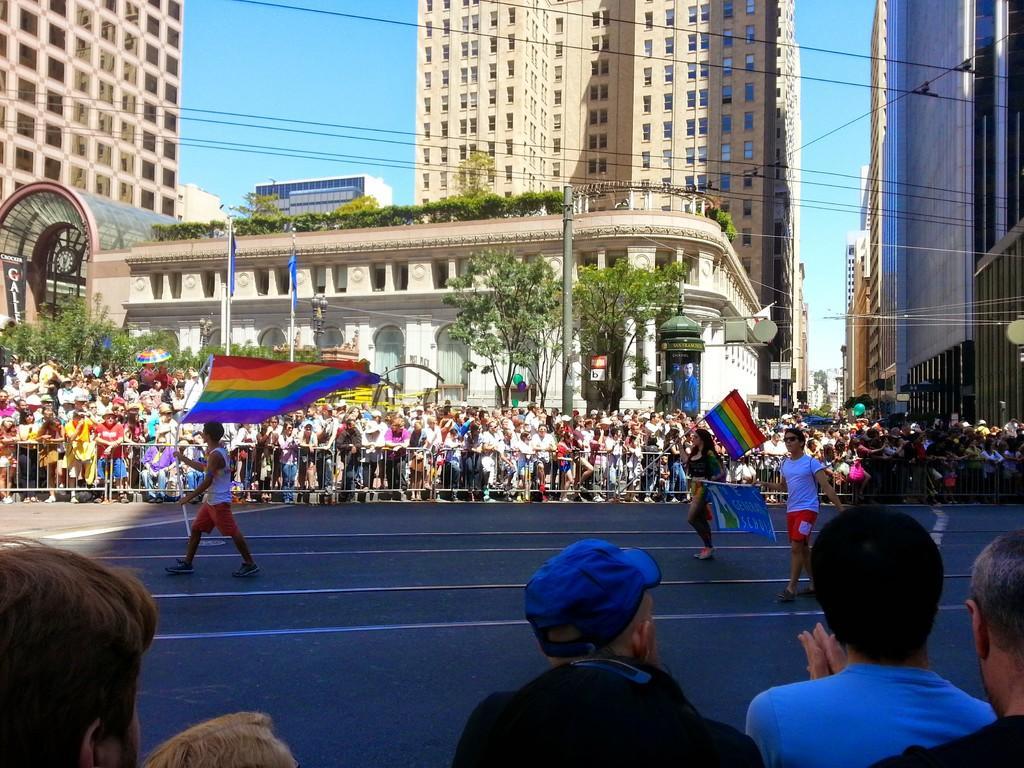Could you give a brief overview of what you see in this image? In this image, in the middle, we can see a group of people are holding flags and walking on the road. In the background, we can see a group of people, metal grill, building, trees, plants, electrical wires, hoardings. At the top, we can see a sky, at the bottom, we can see a group of people. 